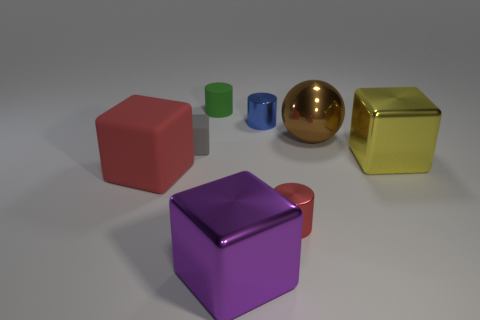What is the tiny gray cube made of?
Make the answer very short. Rubber. How many other objects are there of the same material as the small cube?
Your answer should be compact. 2. The cube on the right side of the tiny metallic object that is behind the big cube on the left side of the rubber cylinder is what color?
Make the answer very short. Yellow. There is a red object on the right side of the metal cube that is in front of the red cube; what shape is it?
Keep it short and to the point. Cylinder. Are there more tiny things that are right of the small green object than brown shiny spheres?
Your answer should be compact. Yes. Is the shape of the tiny metallic object in front of the brown object the same as  the blue metallic object?
Provide a short and direct response. Yes. Are there any large yellow objects of the same shape as the small gray thing?
Keep it short and to the point. Yes. How many objects are either metal cubes on the right side of the blue cylinder or big brown rubber cubes?
Offer a terse response. 1. Are there more tiny red metal objects than tiny shiny cylinders?
Provide a succinct answer. No. Are there any red things of the same size as the rubber cylinder?
Your answer should be very brief. Yes. 